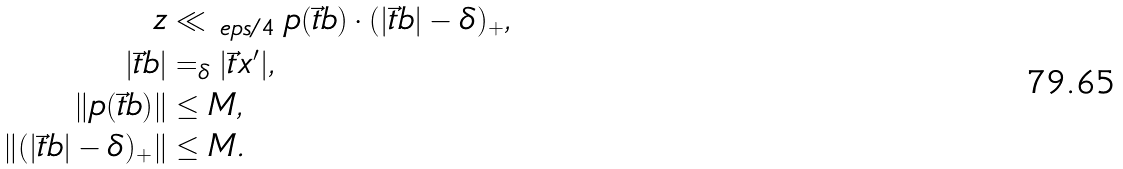<formula> <loc_0><loc_0><loc_500><loc_500>z & \ll _ { \ e p s / 4 } p ( \vec { t } { b } ) \cdot ( | \vec { t } { b } | - \delta ) _ { + } , \\ | \vec { t } { b } | & = _ { \delta } | \vec { t } { x } ^ { \prime } | , \\ \| p ( \vec { t } { b } ) \| & \leq M , \\ \| ( | \vec { t } { b } | - \delta ) _ { + } \| & \leq M .</formula> 